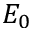Convert formula to latex. <formula><loc_0><loc_0><loc_500><loc_500>E _ { 0 }</formula> 